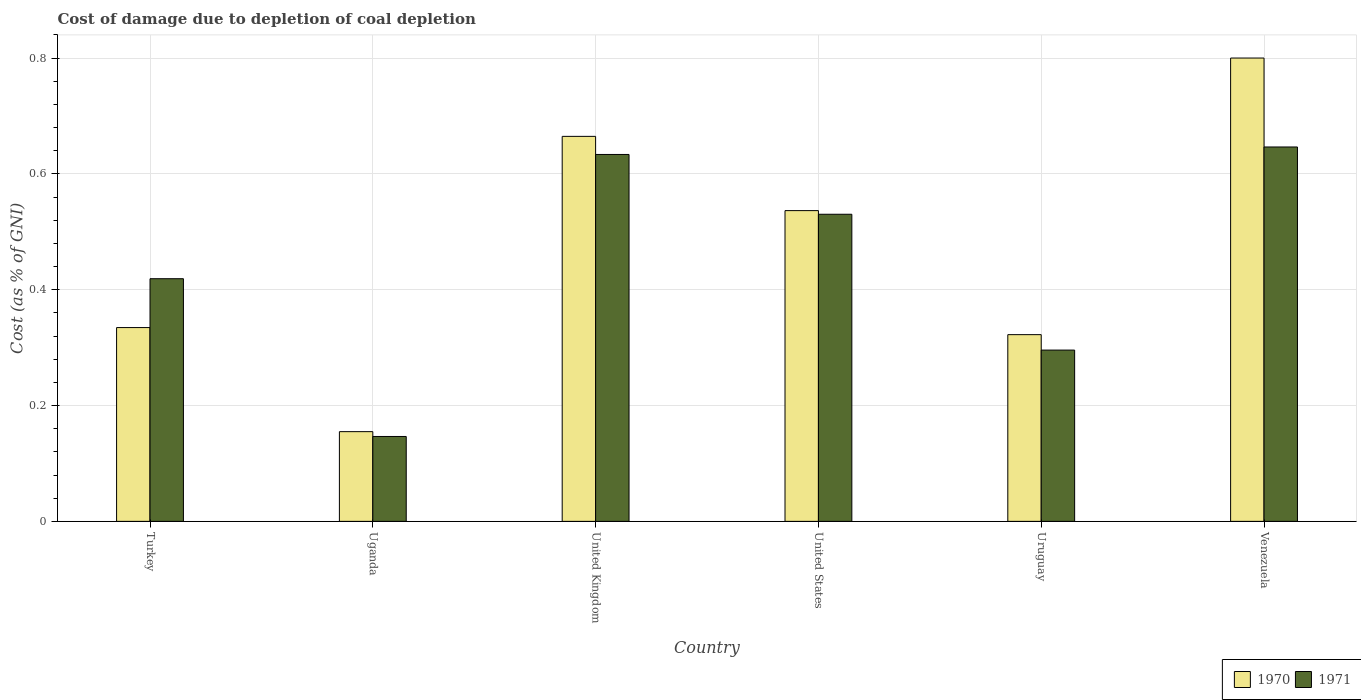How many different coloured bars are there?
Provide a succinct answer. 2. Are the number of bars on each tick of the X-axis equal?
Make the answer very short. Yes. How many bars are there on the 2nd tick from the left?
Give a very brief answer. 2. What is the cost of damage caused due to coal depletion in 1971 in Turkey?
Keep it short and to the point. 0.42. Across all countries, what is the maximum cost of damage caused due to coal depletion in 1971?
Your answer should be compact. 0.65. Across all countries, what is the minimum cost of damage caused due to coal depletion in 1971?
Keep it short and to the point. 0.15. In which country was the cost of damage caused due to coal depletion in 1970 maximum?
Offer a terse response. Venezuela. In which country was the cost of damage caused due to coal depletion in 1970 minimum?
Keep it short and to the point. Uganda. What is the total cost of damage caused due to coal depletion in 1971 in the graph?
Ensure brevity in your answer.  2.67. What is the difference between the cost of damage caused due to coal depletion in 1970 in Uganda and that in United Kingdom?
Provide a succinct answer. -0.51. What is the difference between the cost of damage caused due to coal depletion in 1971 in Turkey and the cost of damage caused due to coal depletion in 1970 in United Kingdom?
Make the answer very short. -0.25. What is the average cost of damage caused due to coal depletion in 1971 per country?
Offer a very short reply. 0.45. What is the difference between the cost of damage caused due to coal depletion of/in 1971 and cost of damage caused due to coal depletion of/in 1970 in United Kingdom?
Make the answer very short. -0.03. In how many countries, is the cost of damage caused due to coal depletion in 1971 greater than 0.28 %?
Give a very brief answer. 5. What is the ratio of the cost of damage caused due to coal depletion in 1971 in United Kingdom to that in United States?
Provide a short and direct response. 1.19. Is the cost of damage caused due to coal depletion in 1970 in United States less than that in Venezuela?
Make the answer very short. Yes. Is the difference between the cost of damage caused due to coal depletion in 1971 in Turkey and Venezuela greater than the difference between the cost of damage caused due to coal depletion in 1970 in Turkey and Venezuela?
Provide a succinct answer. Yes. What is the difference between the highest and the second highest cost of damage caused due to coal depletion in 1970?
Offer a terse response. 0.14. What is the difference between the highest and the lowest cost of damage caused due to coal depletion in 1970?
Offer a very short reply. 0.65. Is the sum of the cost of damage caused due to coal depletion in 1970 in Turkey and United Kingdom greater than the maximum cost of damage caused due to coal depletion in 1971 across all countries?
Keep it short and to the point. Yes. What does the 1st bar from the right in United Kingdom represents?
Offer a very short reply. 1971. How many bars are there?
Make the answer very short. 12. Are all the bars in the graph horizontal?
Provide a succinct answer. No. What is the difference between two consecutive major ticks on the Y-axis?
Ensure brevity in your answer.  0.2. Are the values on the major ticks of Y-axis written in scientific E-notation?
Give a very brief answer. No. Where does the legend appear in the graph?
Make the answer very short. Bottom right. How many legend labels are there?
Keep it short and to the point. 2. How are the legend labels stacked?
Your response must be concise. Horizontal. What is the title of the graph?
Offer a terse response. Cost of damage due to depletion of coal depletion. What is the label or title of the Y-axis?
Make the answer very short. Cost (as % of GNI). What is the Cost (as % of GNI) in 1970 in Turkey?
Your response must be concise. 0.33. What is the Cost (as % of GNI) in 1971 in Turkey?
Your response must be concise. 0.42. What is the Cost (as % of GNI) of 1970 in Uganda?
Make the answer very short. 0.15. What is the Cost (as % of GNI) of 1971 in Uganda?
Offer a very short reply. 0.15. What is the Cost (as % of GNI) in 1970 in United Kingdom?
Provide a short and direct response. 0.66. What is the Cost (as % of GNI) of 1971 in United Kingdom?
Make the answer very short. 0.63. What is the Cost (as % of GNI) of 1970 in United States?
Your answer should be very brief. 0.54. What is the Cost (as % of GNI) of 1971 in United States?
Provide a succinct answer. 0.53. What is the Cost (as % of GNI) in 1970 in Uruguay?
Offer a terse response. 0.32. What is the Cost (as % of GNI) in 1971 in Uruguay?
Your response must be concise. 0.3. What is the Cost (as % of GNI) of 1970 in Venezuela?
Ensure brevity in your answer.  0.8. What is the Cost (as % of GNI) of 1971 in Venezuela?
Your answer should be very brief. 0.65. Across all countries, what is the maximum Cost (as % of GNI) of 1970?
Offer a very short reply. 0.8. Across all countries, what is the maximum Cost (as % of GNI) of 1971?
Offer a very short reply. 0.65. Across all countries, what is the minimum Cost (as % of GNI) of 1970?
Provide a succinct answer. 0.15. Across all countries, what is the minimum Cost (as % of GNI) of 1971?
Offer a terse response. 0.15. What is the total Cost (as % of GNI) in 1970 in the graph?
Give a very brief answer. 2.81. What is the total Cost (as % of GNI) in 1971 in the graph?
Your answer should be very brief. 2.67. What is the difference between the Cost (as % of GNI) in 1970 in Turkey and that in Uganda?
Offer a very short reply. 0.18. What is the difference between the Cost (as % of GNI) of 1971 in Turkey and that in Uganda?
Your answer should be very brief. 0.27. What is the difference between the Cost (as % of GNI) of 1970 in Turkey and that in United Kingdom?
Offer a very short reply. -0.33. What is the difference between the Cost (as % of GNI) in 1971 in Turkey and that in United Kingdom?
Offer a very short reply. -0.21. What is the difference between the Cost (as % of GNI) in 1970 in Turkey and that in United States?
Your response must be concise. -0.2. What is the difference between the Cost (as % of GNI) of 1971 in Turkey and that in United States?
Make the answer very short. -0.11. What is the difference between the Cost (as % of GNI) of 1970 in Turkey and that in Uruguay?
Provide a short and direct response. 0.01. What is the difference between the Cost (as % of GNI) in 1971 in Turkey and that in Uruguay?
Your answer should be very brief. 0.12. What is the difference between the Cost (as % of GNI) in 1970 in Turkey and that in Venezuela?
Keep it short and to the point. -0.47. What is the difference between the Cost (as % of GNI) in 1971 in Turkey and that in Venezuela?
Your response must be concise. -0.23. What is the difference between the Cost (as % of GNI) in 1970 in Uganda and that in United Kingdom?
Your answer should be compact. -0.51. What is the difference between the Cost (as % of GNI) of 1971 in Uganda and that in United Kingdom?
Keep it short and to the point. -0.49. What is the difference between the Cost (as % of GNI) of 1970 in Uganda and that in United States?
Offer a very short reply. -0.38. What is the difference between the Cost (as % of GNI) of 1971 in Uganda and that in United States?
Keep it short and to the point. -0.38. What is the difference between the Cost (as % of GNI) of 1970 in Uganda and that in Uruguay?
Your answer should be compact. -0.17. What is the difference between the Cost (as % of GNI) of 1971 in Uganda and that in Uruguay?
Ensure brevity in your answer.  -0.15. What is the difference between the Cost (as % of GNI) of 1970 in Uganda and that in Venezuela?
Make the answer very short. -0.65. What is the difference between the Cost (as % of GNI) in 1971 in Uganda and that in Venezuela?
Provide a short and direct response. -0.5. What is the difference between the Cost (as % of GNI) in 1970 in United Kingdom and that in United States?
Provide a succinct answer. 0.13. What is the difference between the Cost (as % of GNI) in 1971 in United Kingdom and that in United States?
Offer a terse response. 0.1. What is the difference between the Cost (as % of GNI) in 1970 in United Kingdom and that in Uruguay?
Keep it short and to the point. 0.34. What is the difference between the Cost (as % of GNI) in 1971 in United Kingdom and that in Uruguay?
Your answer should be very brief. 0.34. What is the difference between the Cost (as % of GNI) in 1970 in United Kingdom and that in Venezuela?
Provide a succinct answer. -0.14. What is the difference between the Cost (as % of GNI) in 1971 in United Kingdom and that in Venezuela?
Offer a terse response. -0.01. What is the difference between the Cost (as % of GNI) of 1970 in United States and that in Uruguay?
Offer a terse response. 0.21. What is the difference between the Cost (as % of GNI) of 1971 in United States and that in Uruguay?
Your answer should be compact. 0.23. What is the difference between the Cost (as % of GNI) of 1970 in United States and that in Venezuela?
Keep it short and to the point. -0.26. What is the difference between the Cost (as % of GNI) in 1971 in United States and that in Venezuela?
Your response must be concise. -0.12. What is the difference between the Cost (as % of GNI) of 1970 in Uruguay and that in Venezuela?
Your answer should be very brief. -0.48. What is the difference between the Cost (as % of GNI) in 1971 in Uruguay and that in Venezuela?
Your answer should be very brief. -0.35. What is the difference between the Cost (as % of GNI) in 1970 in Turkey and the Cost (as % of GNI) in 1971 in Uganda?
Offer a very short reply. 0.19. What is the difference between the Cost (as % of GNI) of 1970 in Turkey and the Cost (as % of GNI) of 1971 in United Kingdom?
Offer a very short reply. -0.3. What is the difference between the Cost (as % of GNI) in 1970 in Turkey and the Cost (as % of GNI) in 1971 in United States?
Provide a succinct answer. -0.2. What is the difference between the Cost (as % of GNI) of 1970 in Turkey and the Cost (as % of GNI) of 1971 in Uruguay?
Provide a short and direct response. 0.04. What is the difference between the Cost (as % of GNI) in 1970 in Turkey and the Cost (as % of GNI) in 1971 in Venezuela?
Give a very brief answer. -0.31. What is the difference between the Cost (as % of GNI) of 1970 in Uganda and the Cost (as % of GNI) of 1971 in United Kingdom?
Ensure brevity in your answer.  -0.48. What is the difference between the Cost (as % of GNI) in 1970 in Uganda and the Cost (as % of GNI) in 1971 in United States?
Your answer should be very brief. -0.38. What is the difference between the Cost (as % of GNI) of 1970 in Uganda and the Cost (as % of GNI) of 1971 in Uruguay?
Your answer should be compact. -0.14. What is the difference between the Cost (as % of GNI) in 1970 in Uganda and the Cost (as % of GNI) in 1971 in Venezuela?
Provide a short and direct response. -0.49. What is the difference between the Cost (as % of GNI) of 1970 in United Kingdom and the Cost (as % of GNI) of 1971 in United States?
Provide a short and direct response. 0.13. What is the difference between the Cost (as % of GNI) of 1970 in United Kingdom and the Cost (as % of GNI) of 1971 in Uruguay?
Keep it short and to the point. 0.37. What is the difference between the Cost (as % of GNI) of 1970 in United Kingdom and the Cost (as % of GNI) of 1971 in Venezuela?
Your answer should be very brief. 0.02. What is the difference between the Cost (as % of GNI) of 1970 in United States and the Cost (as % of GNI) of 1971 in Uruguay?
Provide a succinct answer. 0.24. What is the difference between the Cost (as % of GNI) of 1970 in United States and the Cost (as % of GNI) of 1971 in Venezuela?
Keep it short and to the point. -0.11. What is the difference between the Cost (as % of GNI) in 1970 in Uruguay and the Cost (as % of GNI) in 1971 in Venezuela?
Provide a succinct answer. -0.32. What is the average Cost (as % of GNI) in 1970 per country?
Keep it short and to the point. 0.47. What is the average Cost (as % of GNI) of 1971 per country?
Ensure brevity in your answer.  0.45. What is the difference between the Cost (as % of GNI) of 1970 and Cost (as % of GNI) of 1971 in Turkey?
Your answer should be very brief. -0.08. What is the difference between the Cost (as % of GNI) of 1970 and Cost (as % of GNI) of 1971 in Uganda?
Your response must be concise. 0.01. What is the difference between the Cost (as % of GNI) in 1970 and Cost (as % of GNI) in 1971 in United Kingdom?
Your response must be concise. 0.03. What is the difference between the Cost (as % of GNI) in 1970 and Cost (as % of GNI) in 1971 in United States?
Give a very brief answer. 0.01. What is the difference between the Cost (as % of GNI) in 1970 and Cost (as % of GNI) in 1971 in Uruguay?
Ensure brevity in your answer.  0.03. What is the difference between the Cost (as % of GNI) in 1970 and Cost (as % of GNI) in 1971 in Venezuela?
Your answer should be compact. 0.15. What is the ratio of the Cost (as % of GNI) of 1970 in Turkey to that in Uganda?
Your response must be concise. 2.16. What is the ratio of the Cost (as % of GNI) of 1971 in Turkey to that in Uganda?
Your answer should be very brief. 2.86. What is the ratio of the Cost (as % of GNI) in 1970 in Turkey to that in United Kingdom?
Provide a succinct answer. 0.5. What is the ratio of the Cost (as % of GNI) in 1971 in Turkey to that in United Kingdom?
Offer a very short reply. 0.66. What is the ratio of the Cost (as % of GNI) of 1970 in Turkey to that in United States?
Keep it short and to the point. 0.62. What is the ratio of the Cost (as % of GNI) in 1971 in Turkey to that in United States?
Ensure brevity in your answer.  0.79. What is the ratio of the Cost (as % of GNI) of 1970 in Turkey to that in Uruguay?
Your answer should be very brief. 1.04. What is the ratio of the Cost (as % of GNI) of 1971 in Turkey to that in Uruguay?
Keep it short and to the point. 1.42. What is the ratio of the Cost (as % of GNI) in 1970 in Turkey to that in Venezuela?
Keep it short and to the point. 0.42. What is the ratio of the Cost (as % of GNI) in 1971 in Turkey to that in Venezuela?
Give a very brief answer. 0.65. What is the ratio of the Cost (as % of GNI) in 1970 in Uganda to that in United Kingdom?
Give a very brief answer. 0.23. What is the ratio of the Cost (as % of GNI) in 1971 in Uganda to that in United Kingdom?
Keep it short and to the point. 0.23. What is the ratio of the Cost (as % of GNI) in 1970 in Uganda to that in United States?
Offer a very short reply. 0.29. What is the ratio of the Cost (as % of GNI) in 1971 in Uganda to that in United States?
Provide a short and direct response. 0.28. What is the ratio of the Cost (as % of GNI) of 1970 in Uganda to that in Uruguay?
Provide a succinct answer. 0.48. What is the ratio of the Cost (as % of GNI) in 1971 in Uganda to that in Uruguay?
Your answer should be very brief. 0.5. What is the ratio of the Cost (as % of GNI) of 1970 in Uganda to that in Venezuela?
Your answer should be compact. 0.19. What is the ratio of the Cost (as % of GNI) in 1971 in Uganda to that in Venezuela?
Ensure brevity in your answer.  0.23. What is the ratio of the Cost (as % of GNI) in 1970 in United Kingdom to that in United States?
Keep it short and to the point. 1.24. What is the ratio of the Cost (as % of GNI) of 1971 in United Kingdom to that in United States?
Provide a succinct answer. 1.19. What is the ratio of the Cost (as % of GNI) in 1970 in United Kingdom to that in Uruguay?
Provide a short and direct response. 2.06. What is the ratio of the Cost (as % of GNI) in 1971 in United Kingdom to that in Uruguay?
Offer a very short reply. 2.14. What is the ratio of the Cost (as % of GNI) in 1970 in United Kingdom to that in Venezuela?
Ensure brevity in your answer.  0.83. What is the ratio of the Cost (as % of GNI) in 1970 in United States to that in Uruguay?
Ensure brevity in your answer.  1.66. What is the ratio of the Cost (as % of GNI) of 1971 in United States to that in Uruguay?
Ensure brevity in your answer.  1.79. What is the ratio of the Cost (as % of GNI) of 1970 in United States to that in Venezuela?
Your answer should be compact. 0.67. What is the ratio of the Cost (as % of GNI) of 1971 in United States to that in Venezuela?
Make the answer very short. 0.82. What is the ratio of the Cost (as % of GNI) in 1970 in Uruguay to that in Venezuela?
Offer a terse response. 0.4. What is the ratio of the Cost (as % of GNI) in 1971 in Uruguay to that in Venezuela?
Provide a short and direct response. 0.46. What is the difference between the highest and the second highest Cost (as % of GNI) of 1970?
Give a very brief answer. 0.14. What is the difference between the highest and the second highest Cost (as % of GNI) of 1971?
Make the answer very short. 0.01. What is the difference between the highest and the lowest Cost (as % of GNI) in 1970?
Your answer should be compact. 0.65. What is the difference between the highest and the lowest Cost (as % of GNI) in 1971?
Keep it short and to the point. 0.5. 